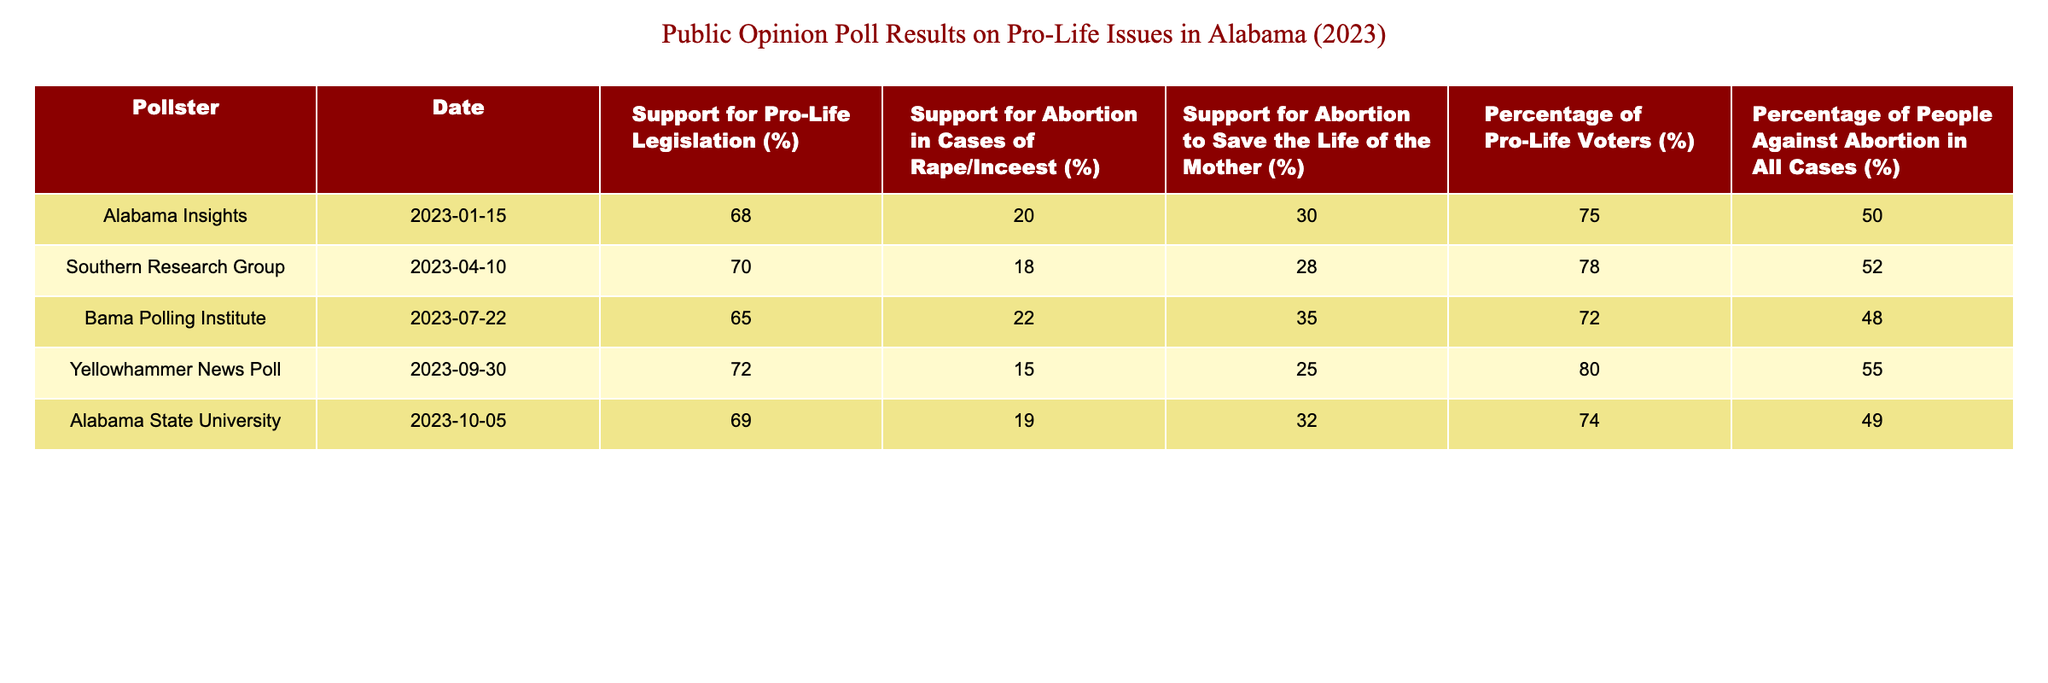What percentage of voters supported pro-life legislation according to the Alabama Insights poll? The table shows that Alabama Insights reported a support for pro-life legislation of 68% on January 15, 2023.
Answer: 68% Which pollster reported the highest support for pro-life legislation? Looking through the table, the highest percentage of support for pro-life legislation is 72%, reported by Yellowhammer News Poll on September 30, 2023.
Answer: Yellowhammer News Poll What is the average support for abortion in cases of rape/incest based on these polls? To find the average, we add the percentages of support: (20 + 18 + 22 + 15 + 19) = 94. Then, we divide by the number of polls, which is 5. So the average is 94/5 = 18.8%.
Answer: 18.8% Is the percentage of people against abortion in all cases higher than 50%? By checking the table, we find that the percentages against abortion in all cases are 50, 52, 48, 55, and 49. Since 50% is not greater than 50%, the answer is no.
Answer: No What was the change in support for pro-life legislation from the Bama Polling Institute in July to the Yellowhammer News Poll in September? The Bama Polling Institute reported 65% support for pro-life legislation in July and Yellowhammer News Poll reported 72% in September. The change is 72 - 65 = 7%.
Answer: 7% Which poll shows the lowest percentage of support for abortion to save the life of the mother? Looking at the column for support for abortion to save the life of the mother, Alabama Insights shows the lowest support at 30%.
Answer: Alabama Insights What percentage of pro-life voters was recorded by the Southern Research Group? The Southern Research Group reported 78% of voters identifying as pro-life, as indicated in the table.
Answer: 78% Did the percentage of support for abortion in cases of rape/incest ever drop below 15% in these polls? By examining the values in the column for abortion in cases of rape/incest, the lowest percentage is 15%, reported by Yellowhammer News Poll. Thus, it never dropped below 15%.
Answer: No How does the average percentage of support for abortion in cases of rape/incest compare to support for abortion to save the life of the mother? The average support for abortion in cases of rape/incest is 18.8% (as previously calculated) and for saving the life of the mother is (30 + 28 + 35 + 25 + 32) = 150/5 = 30%. Since 18.8% is less than 30%, the comparison shows that support for abortion to save the life of the mother is higher.
Answer: Support for abortion to save the life of the mother is higher 